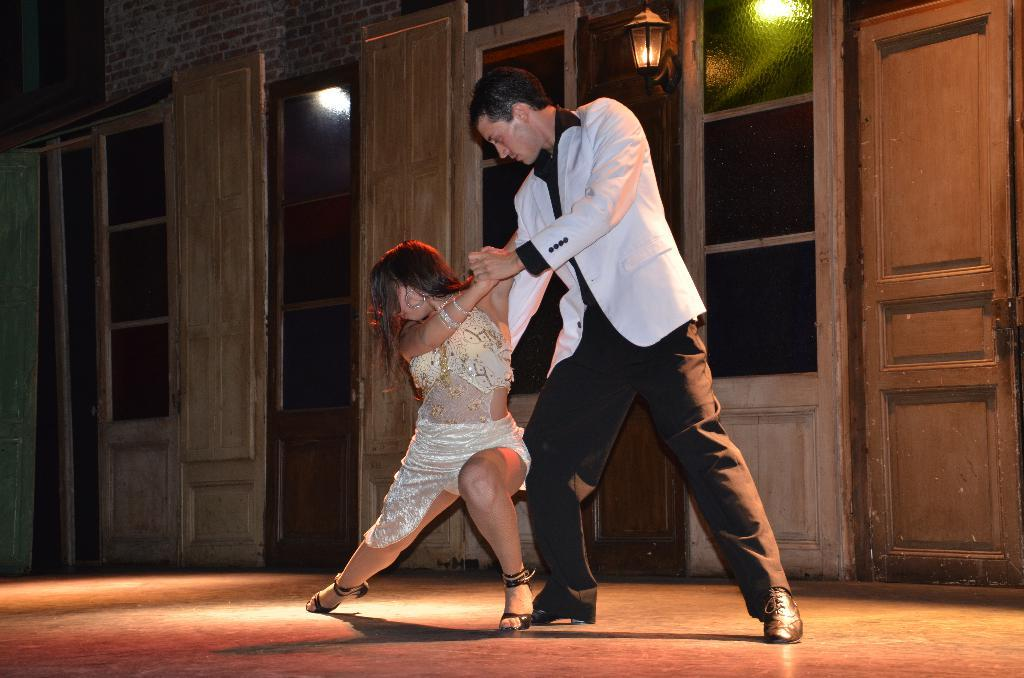How many people are in the image? There is a man and a woman in the image. What are the man and woman doing in the image? The man and woman are dancing. What can be seen in the background of the image? There are windows and doors in the background of the image. Can you describe the lighting in the image? There is a light in the image. What type of comb is the man using to style his hair in the image? There is no comb visible in the image, and the man's hair is not being styled. What fact about the image can you tell me that is not related to the people or the background? The provided facts do not mention any unrelated facts about the image. 